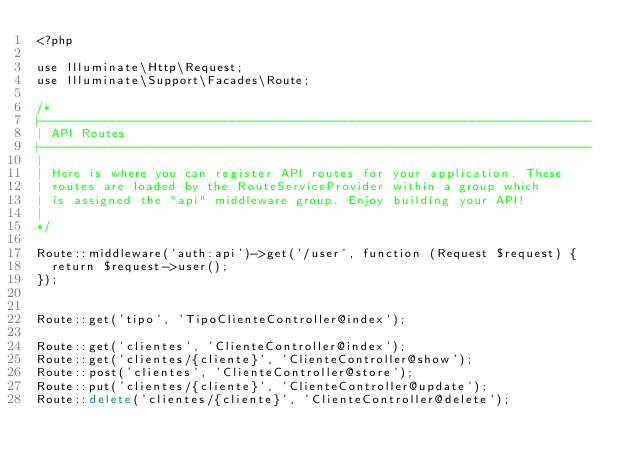Convert code to text. <code><loc_0><loc_0><loc_500><loc_500><_PHP_><?php

use Illuminate\Http\Request;
use Illuminate\Support\Facades\Route;

/*
|--------------------------------------------------------------------------
| API Routes
|--------------------------------------------------------------------------
|
| Here is where you can register API routes for your application. These
| routes are loaded by the RouteServiceProvider within a group which
| is assigned the "api" middleware group. Enjoy building your API!
|
*/

Route::middleware('auth:api')->get('/user', function (Request $request) {
	return $request->user();
});


Route::get('tipo', 'TipoClienteController@index');

Route::get('clientes', 'ClienteController@index');
Route::get('clientes/{cliente}', 'ClienteController@show');
Route::post('clientes', 'ClienteController@store');
Route::put('clientes/{cliente}', 'ClienteController@update');
Route::delete('clientes/{cliente}', 'ClienteController@delete');




</code> 